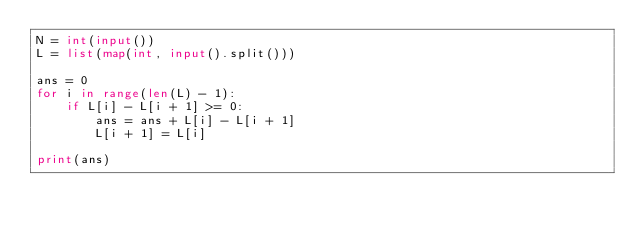<code> <loc_0><loc_0><loc_500><loc_500><_Python_>N = int(input())
L = list(map(int, input().split()))

ans = 0
for i in range(len(L) - 1):
    if L[i] - L[i + 1] >= 0:
        ans = ans + L[i] - L[i + 1]
        L[i + 1] = L[i]

print(ans)</code> 